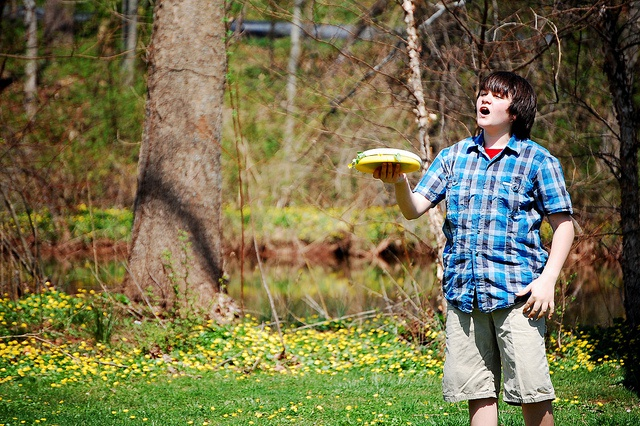Describe the objects in this image and their specific colors. I can see people in black, lightgray, lightblue, and gray tones and frisbee in black, ivory, olive, and khaki tones in this image. 